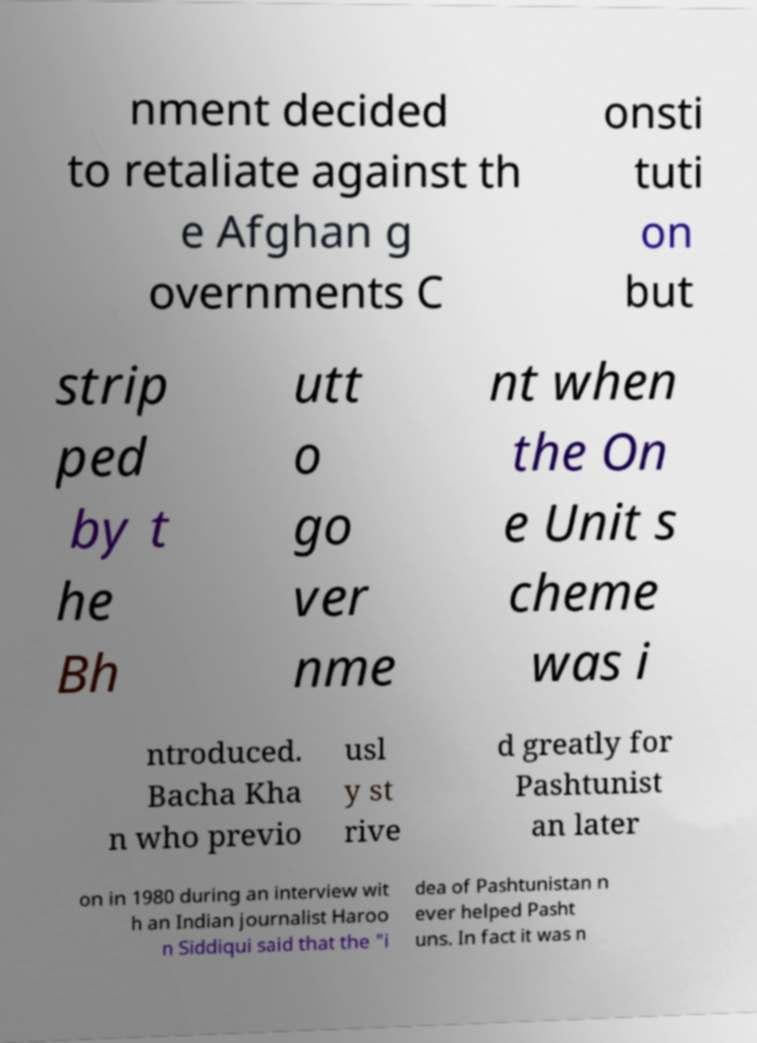What messages or text are displayed in this image? I need them in a readable, typed format. nment decided to retaliate against th e Afghan g overnments C onsti tuti on but strip ped by t he Bh utt o go ver nme nt when the On e Unit s cheme was i ntroduced. Bacha Kha n who previo usl y st rive d greatly for Pashtunist an later on in 1980 during an interview wit h an Indian journalist Haroo n Siddiqui said that the "i dea of Pashtunistan n ever helped Pasht uns. In fact it was n 